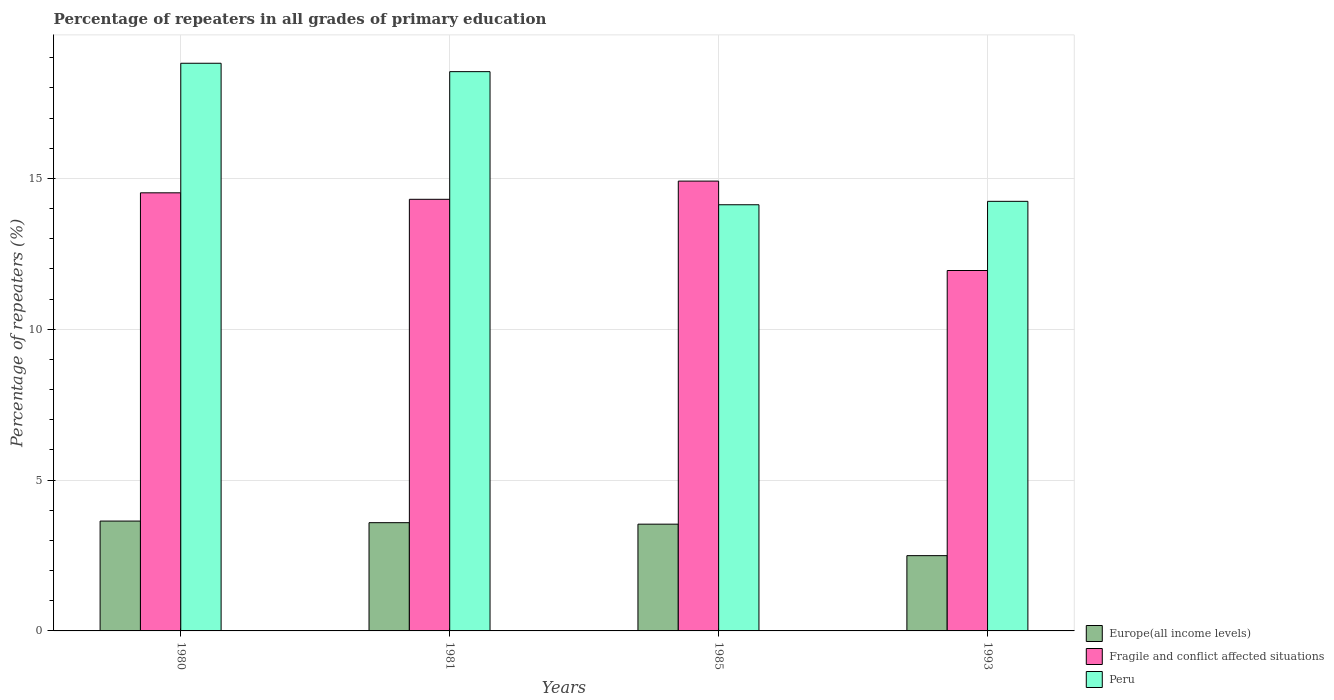Are the number of bars per tick equal to the number of legend labels?
Your answer should be compact. Yes. How many bars are there on the 1st tick from the left?
Provide a succinct answer. 3. How many bars are there on the 2nd tick from the right?
Your answer should be very brief. 3. What is the label of the 1st group of bars from the left?
Provide a succinct answer. 1980. In how many cases, is the number of bars for a given year not equal to the number of legend labels?
Offer a very short reply. 0. What is the percentage of repeaters in Europe(all income levels) in 1993?
Offer a terse response. 2.49. Across all years, what is the maximum percentage of repeaters in Peru?
Provide a succinct answer. 18.82. Across all years, what is the minimum percentage of repeaters in Europe(all income levels)?
Provide a short and direct response. 2.49. What is the total percentage of repeaters in Europe(all income levels) in the graph?
Offer a terse response. 13.26. What is the difference between the percentage of repeaters in Peru in 1981 and that in 1985?
Give a very brief answer. 4.41. What is the difference between the percentage of repeaters in Peru in 1981 and the percentage of repeaters in Fragile and conflict affected situations in 1980?
Give a very brief answer. 4.02. What is the average percentage of repeaters in Europe(all income levels) per year?
Your response must be concise. 3.32. In the year 1981, what is the difference between the percentage of repeaters in Europe(all income levels) and percentage of repeaters in Peru?
Ensure brevity in your answer.  -14.95. In how many years, is the percentage of repeaters in Peru greater than 14 %?
Make the answer very short. 4. What is the ratio of the percentage of repeaters in Europe(all income levels) in 1980 to that in 1981?
Offer a terse response. 1.01. Is the difference between the percentage of repeaters in Europe(all income levels) in 1980 and 1993 greater than the difference between the percentage of repeaters in Peru in 1980 and 1993?
Your answer should be very brief. No. What is the difference between the highest and the second highest percentage of repeaters in Europe(all income levels)?
Ensure brevity in your answer.  0.05. What is the difference between the highest and the lowest percentage of repeaters in Europe(all income levels)?
Offer a very short reply. 1.15. In how many years, is the percentage of repeaters in Europe(all income levels) greater than the average percentage of repeaters in Europe(all income levels) taken over all years?
Give a very brief answer. 3. Is the sum of the percentage of repeaters in Peru in 1980 and 1981 greater than the maximum percentage of repeaters in Europe(all income levels) across all years?
Your response must be concise. Yes. What does the 2nd bar from the right in 1993 represents?
Your answer should be very brief. Fragile and conflict affected situations. Are all the bars in the graph horizontal?
Give a very brief answer. No. What is the difference between two consecutive major ticks on the Y-axis?
Ensure brevity in your answer.  5. Are the values on the major ticks of Y-axis written in scientific E-notation?
Provide a succinct answer. No. Does the graph contain any zero values?
Your answer should be compact. No. How many legend labels are there?
Your response must be concise. 3. How are the legend labels stacked?
Your response must be concise. Vertical. What is the title of the graph?
Ensure brevity in your answer.  Percentage of repeaters in all grades of primary education. What is the label or title of the X-axis?
Keep it short and to the point. Years. What is the label or title of the Y-axis?
Offer a very short reply. Percentage of repeaters (%). What is the Percentage of repeaters (%) of Europe(all income levels) in 1980?
Provide a short and direct response. 3.64. What is the Percentage of repeaters (%) in Fragile and conflict affected situations in 1980?
Give a very brief answer. 14.52. What is the Percentage of repeaters (%) in Peru in 1980?
Provide a short and direct response. 18.82. What is the Percentage of repeaters (%) in Europe(all income levels) in 1981?
Keep it short and to the point. 3.59. What is the Percentage of repeaters (%) of Fragile and conflict affected situations in 1981?
Offer a very short reply. 14.31. What is the Percentage of repeaters (%) in Peru in 1981?
Offer a terse response. 18.54. What is the Percentage of repeaters (%) of Europe(all income levels) in 1985?
Provide a succinct answer. 3.54. What is the Percentage of repeaters (%) of Fragile and conflict affected situations in 1985?
Make the answer very short. 14.91. What is the Percentage of repeaters (%) in Peru in 1985?
Ensure brevity in your answer.  14.13. What is the Percentage of repeaters (%) of Europe(all income levels) in 1993?
Your answer should be compact. 2.49. What is the Percentage of repeaters (%) in Fragile and conflict affected situations in 1993?
Provide a short and direct response. 11.95. What is the Percentage of repeaters (%) of Peru in 1993?
Offer a very short reply. 14.24. Across all years, what is the maximum Percentage of repeaters (%) in Europe(all income levels)?
Your answer should be compact. 3.64. Across all years, what is the maximum Percentage of repeaters (%) of Fragile and conflict affected situations?
Offer a terse response. 14.91. Across all years, what is the maximum Percentage of repeaters (%) in Peru?
Give a very brief answer. 18.82. Across all years, what is the minimum Percentage of repeaters (%) in Europe(all income levels)?
Offer a very short reply. 2.49. Across all years, what is the minimum Percentage of repeaters (%) in Fragile and conflict affected situations?
Offer a terse response. 11.95. Across all years, what is the minimum Percentage of repeaters (%) of Peru?
Your answer should be compact. 14.13. What is the total Percentage of repeaters (%) in Europe(all income levels) in the graph?
Ensure brevity in your answer.  13.26. What is the total Percentage of repeaters (%) of Fragile and conflict affected situations in the graph?
Offer a very short reply. 55.68. What is the total Percentage of repeaters (%) in Peru in the graph?
Your answer should be compact. 65.72. What is the difference between the Percentage of repeaters (%) in Europe(all income levels) in 1980 and that in 1981?
Provide a succinct answer. 0.05. What is the difference between the Percentage of repeaters (%) in Fragile and conflict affected situations in 1980 and that in 1981?
Your answer should be compact. 0.21. What is the difference between the Percentage of repeaters (%) of Peru in 1980 and that in 1981?
Provide a succinct answer. 0.28. What is the difference between the Percentage of repeaters (%) in Europe(all income levels) in 1980 and that in 1985?
Give a very brief answer. 0.1. What is the difference between the Percentage of repeaters (%) in Fragile and conflict affected situations in 1980 and that in 1985?
Offer a very short reply. -0.39. What is the difference between the Percentage of repeaters (%) in Peru in 1980 and that in 1985?
Keep it short and to the point. 4.69. What is the difference between the Percentage of repeaters (%) of Europe(all income levels) in 1980 and that in 1993?
Your response must be concise. 1.15. What is the difference between the Percentage of repeaters (%) of Fragile and conflict affected situations in 1980 and that in 1993?
Your answer should be very brief. 2.58. What is the difference between the Percentage of repeaters (%) in Peru in 1980 and that in 1993?
Ensure brevity in your answer.  4.58. What is the difference between the Percentage of repeaters (%) in Europe(all income levels) in 1981 and that in 1985?
Provide a short and direct response. 0.05. What is the difference between the Percentage of repeaters (%) in Fragile and conflict affected situations in 1981 and that in 1985?
Offer a very short reply. -0.6. What is the difference between the Percentage of repeaters (%) in Peru in 1981 and that in 1985?
Make the answer very short. 4.41. What is the difference between the Percentage of repeaters (%) in Europe(all income levels) in 1981 and that in 1993?
Make the answer very short. 1.09. What is the difference between the Percentage of repeaters (%) in Fragile and conflict affected situations in 1981 and that in 1993?
Keep it short and to the point. 2.36. What is the difference between the Percentage of repeaters (%) of Peru in 1981 and that in 1993?
Provide a short and direct response. 4.3. What is the difference between the Percentage of repeaters (%) of Europe(all income levels) in 1985 and that in 1993?
Keep it short and to the point. 1.04. What is the difference between the Percentage of repeaters (%) in Fragile and conflict affected situations in 1985 and that in 1993?
Offer a terse response. 2.96. What is the difference between the Percentage of repeaters (%) of Peru in 1985 and that in 1993?
Your answer should be very brief. -0.11. What is the difference between the Percentage of repeaters (%) in Europe(all income levels) in 1980 and the Percentage of repeaters (%) in Fragile and conflict affected situations in 1981?
Provide a short and direct response. -10.66. What is the difference between the Percentage of repeaters (%) of Europe(all income levels) in 1980 and the Percentage of repeaters (%) of Peru in 1981?
Provide a short and direct response. -14.9. What is the difference between the Percentage of repeaters (%) of Fragile and conflict affected situations in 1980 and the Percentage of repeaters (%) of Peru in 1981?
Make the answer very short. -4.02. What is the difference between the Percentage of repeaters (%) of Europe(all income levels) in 1980 and the Percentage of repeaters (%) of Fragile and conflict affected situations in 1985?
Your answer should be very brief. -11.27. What is the difference between the Percentage of repeaters (%) in Europe(all income levels) in 1980 and the Percentage of repeaters (%) in Peru in 1985?
Give a very brief answer. -10.48. What is the difference between the Percentage of repeaters (%) in Fragile and conflict affected situations in 1980 and the Percentage of repeaters (%) in Peru in 1985?
Provide a succinct answer. 0.4. What is the difference between the Percentage of repeaters (%) of Europe(all income levels) in 1980 and the Percentage of repeaters (%) of Fragile and conflict affected situations in 1993?
Your answer should be very brief. -8.3. What is the difference between the Percentage of repeaters (%) in Europe(all income levels) in 1980 and the Percentage of repeaters (%) in Peru in 1993?
Your response must be concise. -10.6. What is the difference between the Percentage of repeaters (%) in Fragile and conflict affected situations in 1980 and the Percentage of repeaters (%) in Peru in 1993?
Your response must be concise. 0.28. What is the difference between the Percentage of repeaters (%) in Europe(all income levels) in 1981 and the Percentage of repeaters (%) in Fragile and conflict affected situations in 1985?
Offer a terse response. -11.32. What is the difference between the Percentage of repeaters (%) in Europe(all income levels) in 1981 and the Percentage of repeaters (%) in Peru in 1985?
Offer a very short reply. -10.54. What is the difference between the Percentage of repeaters (%) of Fragile and conflict affected situations in 1981 and the Percentage of repeaters (%) of Peru in 1985?
Your response must be concise. 0.18. What is the difference between the Percentage of repeaters (%) in Europe(all income levels) in 1981 and the Percentage of repeaters (%) in Fragile and conflict affected situations in 1993?
Make the answer very short. -8.36. What is the difference between the Percentage of repeaters (%) of Europe(all income levels) in 1981 and the Percentage of repeaters (%) of Peru in 1993?
Ensure brevity in your answer.  -10.65. What is the difference between the Percentage of repeaters (%) of Fragile and conflict affected situations in 1981 and the Percentage of repeaters (%) of Peru in 1993?
Ensure brevity in your answer.  0.07. What is the difference between the Percentage of repeaters (%) in Europe(all income levels) in 1985 and the Percentage of repeaters (%) in Fragile and conflict affected situations in 1993?
Your answer should be very brief. -8.41. What is the difference between the Percentage of repeaters (%) of Fragile and conflict affected situations in 1985 and the Percentage of repeaters (%) of Peru in 1993?
Offer a very short reply. 0.67. What is the average Percentage of repeaters (%) of Europe(all income levels) per year?
Your response must be concise. 3.32. What is the average Percentage of repeaters (%) in Fragile and conflict affected situations per year?
Offer a very short reply. 13.92. What is the average Percentage of repeaters (%) in Peru per year?
Your response must be concise. 16.43. In the year 1980, what is the difference between the Percentage of repeaters (%) of Europe(all income levels) and Percentage of repeaters (%) of Fragile and conflict affected situations?
Provide a succinct answer. -10.88. In the year 1980, what is the difference between the Percentage of repeaters (%) in Europe(all income levels) and Percentage of repeaters (%) in Peru?
Provide a succinct answer. -15.17. In the year 1980, what is the difference between the Percentage of repeaters (%) of Fragile and conflict affected situations and Percentage of repeaters (%) of Peru?
Offer a terse response. -4.29. In the year 1981, what is the difference between the Percentage of repeaters (%) in Europe(all income levels) and Percentage of repeaters (%) in Fragile and conflict affected situations?
Offer a terse response. -10.72. In the year 1981, what is the difference between the Percentage of repeaters (%) in Europe(all income levels) and Percentage of repeaters (%) in Peru?
Make the answer very short. -14.95. In the year 1981, what is the difference between the Percentage of repeaters (%) of Fragile and conflict affected situations and Percentage of repeaters (%) of Peru?
Ensure brevity in your answer.  -4.23. In the year 1985, what is the difference between the Percentage of repeaters (%) in Europe(all income levels) and Percentage of repeaters (%) in Fragile and conflict affected situations?
Offer a terse response. -11.37. In the year 1985, what is the difference between the Percentage of repeaters (%) in Europe(all income levels) and Percentage of repeaters (%) in Peru?
Make the answer very short. -10.59. In the year 1985, what is the difference between the Percentage of repeaters (%) in Fragile and conflict affected situations and Percentage of repeaters (%) in Peru?
Your response must be concise. 0.78. In the year 1993, what is the difference between the Percentage of repeaters (%) in Europe(all income levels) and Percentage of repeaters (%) in Fragile and conflict affected situations?
Ensure brevity in your answer.  -9.45. In the year 1993, what is the difference between the Percentage of repeaters (%) of Europe(all income levels) and Percentage of repeaters (%) of Peru?
Provide a succinct answer. -11.74. In the year 1993, what is the difference between the Percentage of repeaters (%) of Fragile and conflict affected situations and Percentage of repeaters (%) of Peru?
Offer a very short reply. -2.29. What is the ratio of the Percentage of repeaters (%) in Europe(all income levels) in 1980 to that in 1981?
Provide a short and direct response. 1.01. What is the ratio of the Percentage of repeaters (%) of Fragile and conflict affected situations in 1980 to that in 1981?
Your answer should be very brief. 1.01. What is the ratio of the Percentage of repeaters (%) in Fragile and conflict affected situations in 1980 to that in 1985?
Offer a very short reply. 0.97. What is the ratio of the Percentage of repeaters (%) of Peru in 1980 to that in 1985?
Your answer should be compact. 1.33. What is the ratio of the Percentage of repeaters (%) of Europe(all income levels) in 1980 to that in 1993?
Your answer should be very brief. 1.46. What is the ratio of the Percentage of repeaters (%) of Fragile and conflict affected situations in 1980 to that in 1993?
Your answer should be compact. 1.22. What is the ratio of the Percentage of repeaters (%) of Peru in 1980 to that in 1993?
Offer a terse response. 1.32. What is the ratio of the Percentage of repeaters (%) in Fragile and conflict affected situations in 1981 to that in 1985?
Your response must be concise. 0.96. What is the ratio of the Percentage of repeaters (%) of Peru in 1981 to that in 1985?
Ensure brevity in your answer.  1.31. What is the ratio of the Percentage of repeaters (%) of Europe(all income levels) in 1981 to that in 1993?
Offer a very short reply. 1.44. What is the ratio of the Percentage of repeaters (%) of Fragile and conflict affected situations in 1981 to that in 1993?
Provide a succinct answer. 1.2. What is the ratio of the Percentage of repeaters (%) of Peru in 1981 to that in 1993?
Offer a very short reply. 1.3. What is the ratio of the Percentage of repeaters (%) in Europe(all income levels) in 1985 to that in 1993?
Provide a succinct answer. 1.42. What is the ratio of the Percentage of repeaters (%) in Fragile and conflict affected situations in 1985 to that in 1993?
Ensure brevity in your answer.  1.25. What is the ratio of the Percentage of repeaters (%) in Peru in 1985 to that in 1993?
Ensure brevity in your answer.  0.99. What is the difference between the highest and the second highest Percentage of repeaters (%) of Europe(all income levels)?
Your answer should be very brief. 0.05. What is the difference between the highest and the second highest Percentage of repeaters (%) of Fragile and conflict affected situations?
Give a very brief answer. 0.39. What is the difference between the highest and the second highest Percentage of repeaters (%) in Peru?
Offer a terse response. 0.28. What is the difference between the highest and the lowest Percentage of repeaters (%) in Europe(all income levels)?
Provide a succinct answer. 1.15. What is the difference between the highest and the lowest Percentage of repeaters (%) in Fragile and conflict affected situations?
Ensure brevity in your answer.  2.96. What is the difference between the highest and the lowest Percentage of repeaters (%) in Peru?
Keep it short and to the point. 4.69. 